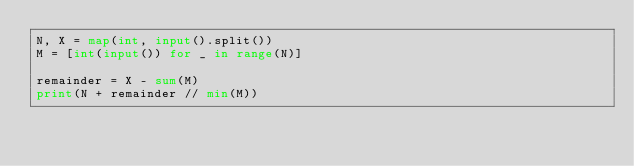<code> <loc_0><loc_0><loc_500><loc_500><_Python_>N, X = map(int, input().split())
M = [int(input()) for _ in range(N)]

remainder = X - sum(M)
print(N + remainder // min(M))</code> 